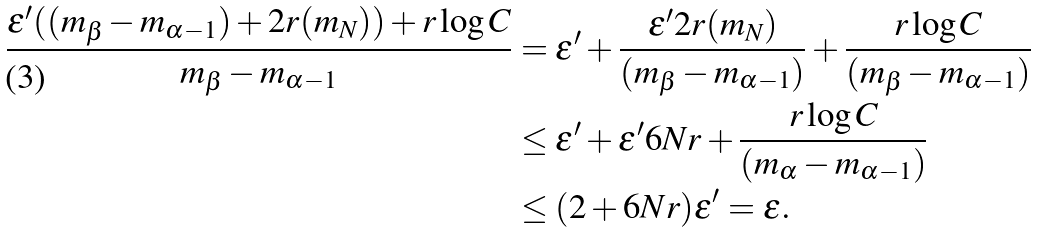Convert formula to latex. <formula><loc_0><loc_0><loc_500><loc_500>\frac { \epsilon ^ { \prime } ( ( m _ { \beta } - m _ { \alpha - 1 } ) + 2 r ( m _ { N } ) ) + r \log { C } } { m _ { \beta } - m _ { \alpha - 1 } } & = \epsilon ^ { \prime } + \frac { \epsilon ^ { \prime } 2 r ( m _ { N } ) } { ( m _ { \beta } - m _ { \alpha - 1 } ) } + \frac { r \log { C } } { ( m _ { \beta } - m _ { \alpha - 1 } ) } \\ & \leq \epsilon ^ { \prime } + \epsilon ^ { \prime } 6 N r + \frac { r \log { C } } { ( m _ { \alpha } - m _ { \alpha - 1 } ) } \\ & \leq ( 2 + 6 N r ) \epsilon ^ { \prime } = \epsilon .</formula> 